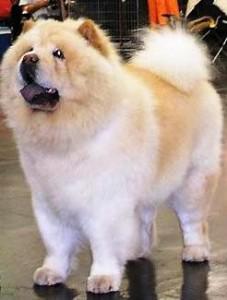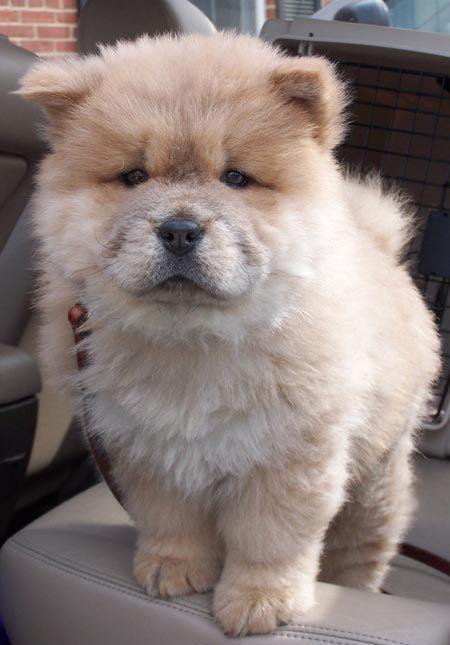The first image is the image on the left, the second image is the image on the right. Given the left and right images, does the statement "All images show only very young chow pups, and each image shows the same number." hold true? Answer yes or no. No. The first image is the image on the left, the second image is the image on the right. For the images shown, is this caption "There is a person holding exactly one dog in the image on the left" true? Answer yes or no. No. 